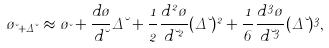<formula> <loc_0><loc_0><loc_500><loc_500>\tau _ { \lambda + \Delta \lambda } \approx \tau _ { \lambda } + \frac { d \tau } { d \lambda } \Delta \lambda + \frac { 1 } { 2 } \frac { d ^ { 2 } \tau } { d \lambda ^ { 2 } } ( \Delta \lambda ) ^ { 2 } + \frac { 1 } { 6 } \frac { d ^ { 3 } \tau } { d \lambda ^ { 3 } } ( \Delta \lambda ) ^ { 3 } ,</formula> 